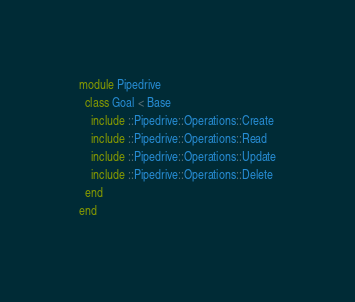Convert code to text. <code><loc_0><loc_0><loc_500><loc_500><_Ruby_>module Pipedrive
  class Goal < Base
    include ::Pipedrive::Operations::Create
    include ::Pipedrive::Operations::Read
    include ::Pipedrive::Operations::Update
    include ::Pipedrive::Operations::Delete
  end
end
</code> 